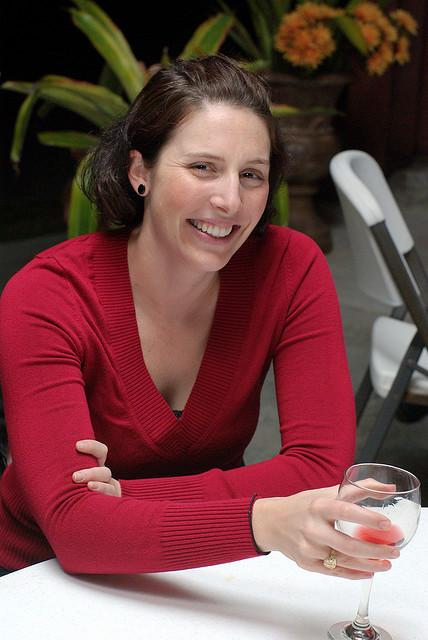What drink goes in this type of glass? Please explain your reasoning. wine. This is a specialized glass for an alcoholic beverage. 